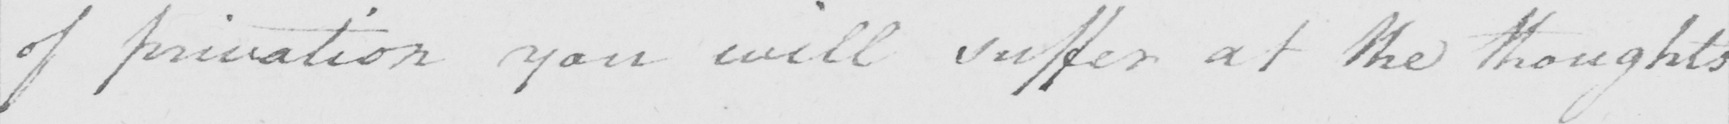Can you read and transcribe this handwriting? of privation you will suffer at the thoughts 